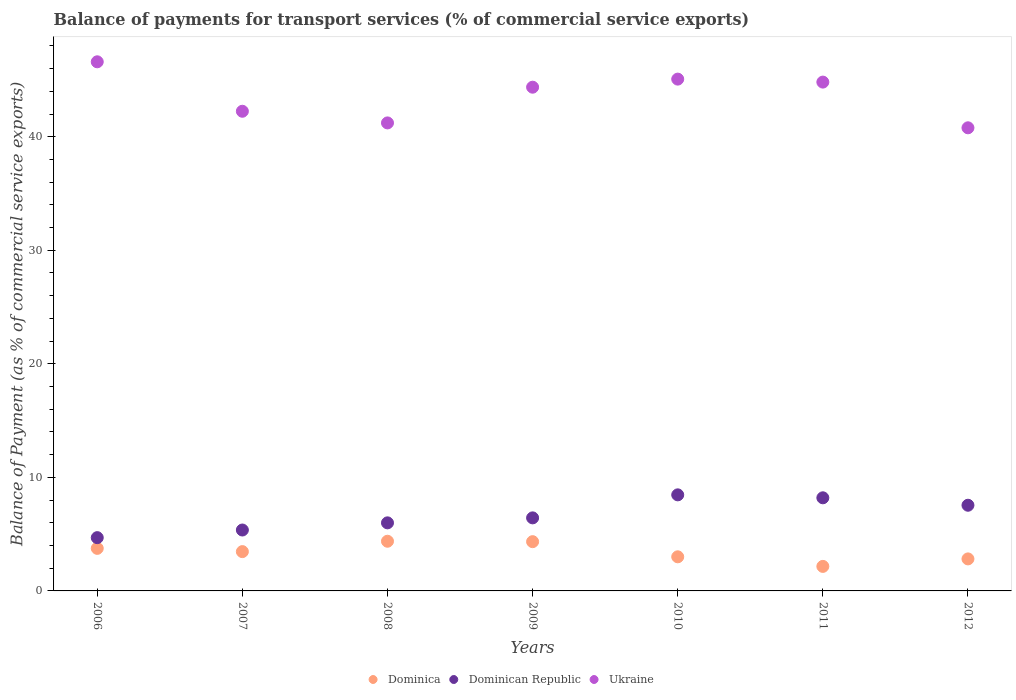How many different coloured dotlines are there?
Give a very brief answer. 3. Is the number of dotlines equal to the number of legend labels?
Your response must be concise. Yes. What is the balance of payments for transport services in Dominican Republic in 2007?
Provide a short and direct response. 5.36. Across all years, what is the maximum balance of payments for transport services in Dominica?
Make the answer very short. 4.37. Across all years, what is the minimum balance of payments for transport services in Dominica?
Provide a succinct answer. 2.16. In which year was the balance of payments for transport services in Dominican Republic maximum?
Your response must be concise. 2010. In which year was the balance of payments for transport services in Dominica minimum?
Your answer should be very brief. 2011. What is the total balance of payments for transport services in Dominican Republic in the graph?
Keep it short and to the point. 46.69. What is the difference between the balance of payments for transport services in Dominica in 2008 and that in 2012?
Your answer should be compact. 1.56. What is the difference between the balance of payments for transport services in Dominica in 2008 and the balance of payments for transport services in Ukraine in 2007?
Offer a terse response. -37.87. What is the average balance of payments for transport services in Ukraine per year?
Your response must be concise. 43.58. In the year 2010, what is the difference between the balance of payments for transport services in Dominican Republic and balance of payments for transport services in Ukraine?
Keep it short and to the point. -36.61. In how many years, is the balance of payments for transport services in Dominica greater than 18 %?
Your answer should be very brief. 0. What is the ratio of the balance of payments for transport services in Ukraine in 2007 to that in 2010?
Offer a very short reply. 0.94. Is the difference between the balance of payments for transport services in Dominican Republic in 2008 and 2010 greater than the difference between the balance of payments for transport services in Ukraine in 2008 and 2010?
Provide a succinct answer. Yes. What is the difference between the highest and the second highest balance of payments for transport services in Dominican Republic?
Provide a short and direct response. 0.26. What is the difference between the highest and the lowest balance of payments for transport services in Ukraine?
Provide a succinct answer. 5.81. Does the balance of payments for transport services in Dominica monotonically increase over the years?
Provide a short and direct response. No. How many dotlines are there?
Your response must be concise. 3. Are the values on the major ticks of Y-axis written in scientific E-notation?
Keep it short and to the point. No. Does the graph contain any zero values?
Keep it short and to the point. No. How many legend labels are there?
Keep it short and to the point. 3. What is the title of the graph?
Your answer should be very brief. Balance of payments for transport services (% of commercial service exports). What is the label or title of the Y-axis?
Offer a very short reply. Balance of Payment (as % of commercial service exports). What is the Balance of Payment (as % of commercial service exports) of Dominica in 2006?
Provide a short and direct response. 3.75. What is the Balance of Payment (as % of commercial service exports) in Dominican Republic in 2006?
Offer a terse response. 4.69. What is the Balance of Payment (as % of commercial service exports) in Ukraine in 2006?
Offer a terse response. 46.6. What is the Balance of Payment (as % of commercial service exports) of Dominica in 2007?
Give a very brief answer. 3.46. What is the Balance of Payment (as % of commercial service exports) in Dominican Republic in 2007?
Provide a succinct answer. 5.36. What is the Balance of Payment (as % of commercial service exports) in Ukraine in 2007?
Keep it short and to the point. 42.24. What is the Balance of Payment (as % of commercial service exports) of Dominica in 2008?
Ensure brevity in your answer.  4.37. What is the Balance of Payment (as % of commercial service exports) in Dominican Republic in 2008?
Give a very brief answer. 5.99. What is the Balance of Payment (as % of commercial service exports) in Ukraine in 2008?
Keep it short and to the point. 41.22. What is the Balance of Payment (as % of commercial service exports) of Dominica in 2009?
Ensure brevity in your answer.  4.34. What is the Balance of Payment (as % of commercial service exports) in Dominican Republic in 2009?
Offer a terse response. 6.43. What is the Balance of Payment (as % of commercial service exports) of Ukraine in 2009?
Give a very brief answer. 44.36. What is the Balance of Payment (as % of commercial service exports) of Dominica in 2010?
Offer a very short reply. 3. What is the Balance of Payment (as % of commercial service exports) in Dominican Republic in 2010?
Offer a very short reply. 8.46. What is the Balance of Payment (as % of commercial service exports) of Ukraine in 2010?
Provide a short and direct response. 45.07. What is the Balance of Payment (as % of commercial service exports) in Dominica in 2011?
Provide a short and direct response. 2.16. What is the Balance of Payment (as % of commercial service exports) of Dominican Republic in 2011?
Keep it short and to the point. 8.2. What is the Balance of Payment (as % of commercial service exports) in Ukraine in 2011?
Your answer should be compact. 44.81. What is the Balance of Payment (as % of commercial service exports) in Dominica in 2012?
Give a very brief answer. 2.82. What is the Balance of Payment (as % of commercial service exports) in Dominican Republic in 2012?
Provide a short and direct response. 7.55. What is the Balance of Payment (as % of commercial service exports) of Ukraine in 2012?
Your response must be concise. 40.79. Across all years, what is the maximum Balance of Payment (as % of commercial service exports) in Dominica?
Provide a succinct answer. 4.37. Across all years, what is the maximum Balance of Payment (as % of commercial service exports) in Dominican Republic?
Ensure brevity in your answer.  8.46. Across all years, what is the maximum Balance of Payment (as % of commercial service exports) in Ukraine?
Ensure brevity in your answer.  46.6. Across all years, what is the minimum Balance of Payment (as % of commercial service exports) in Dominica?
Your response must be concise. 2.16. Across all years, what is the minimum Balance of Payment (as % of commercial service exports) of Dominican Republic?
Give a very brief answer. 4.69. Across all years, what is the minimum Balance of Payment (as % of commercial service exports) in Ukraine?
Make the answer very short. 40.79. What is the total Balance of Payment (as % of commercial service exports) of Dominica in the graph?
Offer a terse response. 23.9. What is the total Balance of Payment (as % of commercial service exports) of Dominican Republic in the graph?
Offer a very short reply. 46.69. What is the total Balance of Payment (as % of commercial service exports) of Ukraine in the graph?
Your answer should be compact. 305.09. What is the difference between the Balance of Payment (as % of commercial service exports) of Dominica in 2006 and that in 2007?
Make the answer very short. 0.29. What is the difference between the Balance of Payment (as % of commercial service exports) of Dominican Republic in 2006 and that in 2007?
Ensure brevity in your answer.  -0.67. What is the difference between the Balance of Payment (as % of commercial service exports) of Ukraine in 2006 and that in 2007?
Offer a terse response. 4.36. What is the difference between the Balance of Payment (as % of commercial service exports) in Dominica in 2006 and that in 2008?
Your answer should be compact. -0.63. What is the difference between the Balance of Payment (as % of commercial service exports) in Dominican Republic in 2006 and that in 2008?
Ensure brevity in your answer.  -1.3. What is the difference between the Balance of Payment (as % of commercial service exports) in Ukraine in 2006 and that in 2008?
Provide a succinct answer. 5.38. What is the difference between the Balance of Payment (as % of commercial service exports) of Dominica in 2006 and that in 2009?
Your answer should be very brief. -0.59. What is the difference between the Balance of Payment (as % of commercial service exports) in Dominican Republic in 2006 and that in 2009?
Offer a very short reply. -1.74. What is the difference between the Balance of Payment (as % of commercial service exports) in Ukraine in 2006 and that in 2009?
Your response must be concise. 2.24. What is the difference between the Balance of Payment (as % of commercial service exports) of Dominica in 2006 and that in 2010?
Offer a very short reply. 0.74. What is the difference between the Balance of Payment (as % of commercial service exports) in Dominican Republic in 2006 and that in 2010?
Make the answer very short. -3.77. What is the difference between the Balance of Payment (as % of commercial service exports) of Ukraine in 2006 and that in 2010?
Your answer should be very brief. 1.52. What is the difference between the Balance of Payment (as % of commercial service exports) of Dominica in 2006 and that in 2011?
Give a very brief answer. 1.59. What is the difference between the Balance of Payment (as % of commercial service exports) of Dominican Republic in 2006 and that in 2011?
Keep it short and to the point. -3.51. What is the difference between the Balance of Payment (as % of commercial service exports) of Ukraine in 2006 and that in 2011?
Offer a very short reply. 1.79. What is the difference between the Balance of Payment (as % of commercial service exports) of Dominica in 2006 and that in 2012?
Make the answer very short. 0.93. What is the difference between the Balance of Payment (as % of commercial service exports) in Dominican Republic in 2006 and that in 2012?
Provide a succinct answer. -2.85. What is the difference between the Balance of Payment (as % of commercial service exports) of Ukraine in 2006 and that in 2012?
Your answer should be very brief. 5.81. What is the difference between the Balance of Payment (as % of commercial service exports) in Dominica in 2007 and that in 2008?
Ensure brevity in your answer.  -0.91. What is the difference between the Balance of Payment (as % of commercial service exports) in Dominican Republic in 2007 and that in 2008?
Your answer should be compact. -0.63. What is the difference between the Balance of Payment (as % of commercial service exports) in Ukraine in 2007 and that in 2008?
Offer a very short reply. 1.03. What is the difference between the Balance of Payment (as % of commercial service exports) in Dominica in 2007 and that in 2009?
Offer a very short reply. -0.88. What is the difference between the Balance of Payment (as % of commercial service exports) of Dominican Republic in 2007 and that in 2009?
Provide a short and direct response. -1.07. What is the difference between the Balance of Payment (as % of commercial service exports) of Ukraine in 2007 and that in 2009?
Provide a short and direct response. -2.12. What is the difference between the Balance of Payment (as % of commercial service exports) in Dominica in 2007 and that in 2010?
Provide a succinct answer. 0.46. What is the difference between the Balance of Payment (as % of commercial service exports) in Dominican Republic in 2007 and that in 2010?
Your answer should be compact. -3.1. What is the difference between the Balance of Payment (as % of commercial service exports) in Ukraine in 2007 and that in 2010?
Your answer should be very brief. -2.83. What is the difference between the Balance of Payment (as % of commercial service exports) of Dominica in 2007 and that in 2011?
Keep it short and to the point. 1.3. What is the difference between the Balance of Payment (as % of commercial service exports) in Dominican Republic in 2007 and that in 2011?
Keep it short and to the point. -2.84. What is the difference between the Balance of Payment (as % of commercial service exports) in Ukraine in 2007 and that in 2011?
Your answer should be compact. -2.57. What is the difference between the Balance of Payment (as % of commercial service exports) of Dominica in 2007 and that in 2012?
Your response must be concise. 0.64. What is the difference between the Balance of Payment (as % of commercial service exports) in Dominican Republic in 2007 and that in 2012?
Make the answer very short. -2.18. What is the difference between the Balance of Payment (as % of commercial service exports) of Ukraine in 2007 and that in 2012?
Your answer should be very brief. 1.46. What is the difference between the Balance of Payment (as % of commercial service exports) of Dominica in 2008 and that in 2009?
Ensure brevity in your answer.  0.04. What is the difference between the Balance of Payment (as % of commercial service exports) in Dominican Republic in 2008 and that in 2009?
Provide a succinct answer. -0.44. What is the difference between the Balance of Payment (as % of commercial service exports) of Ukraine in 2008 and that in 2009?
Ensure brevity in your answer.  -3.15. What is the difference between the Balance of Payment (as % of commercial service exports) in Dominica in 2008 and that in 2010?
Your response must be concise. 1.37. What is the difference between the Balance of Payment (as % of commercial service exports) in Dominican Republic in 2008 and that in 2010?
Your response must be concise. -2.47. What is the difference between the Balance of Payment (as % of commercial service exports) in Ukraine in 2008 and that in 2010?
Provide a succinct answer. -3.86. What is the difference between the Balance of Payment (as % of commercial service exports) of Dominica in 2008 and that in 2011?
Your answer should be compact. 2.21. What is the difference between the Balance of Payment (as % of commercial service exports) in Dominican Republic in 2008 and that in 2011?
Give a very brief answer. -2.21. What is the difference between the Balance of Payment (as % of commercial service exports) in Ukraine in 2008 and that in 2011?
Give a very brief answer. -3.59. What is the difference between the Balance of Payment (as % of commercial service exports) of Dominica in 2008 and that in 2012?
Offer a very short reply. 1.56. What is the difference between the Balance of Payment (as % of commercial service exports) of Dominican Republic in 2008 and that in 2012?
Your answer should be compact. -1.55. What is the difference between the Balance of Payment (as % of commercial service exports) of Ukraine in 2008 and that in 2012?
Ensure brevity in your answer.  0.43. What is the difference between the Balance of Payment (as % of commercial service exports) in Dominica in 2009 and that in 2010?
Offer a very short reply. 1.33. What is the difference between the Balance of Payment (as % of commercial service exports) in Dominican Republic in 2009 and that in 2010?
Make the answer very short. -2.03. What is the difference between the Balance of Payment (as % of commercial service exports) of Ukraine in 2009 and that in 2010?
Provide a succinct answer. -0.71. What is the difference between the Balance of Payment (as % of commercial service exports) of Dominica in 2009 and that in 2011?
Provide a short and direct response. 2.18. What is the difference between the Balance of Payment (as % of commercial service exports) in Dominican Republic in 2009 and that in 2011?
Offer a terse response. -1.77. What is the difference between the Balance of Payment (as % of commercial service exports) of Ukraine in 2009 and that in 2011?
Your response must be concise. -0.45. What is the difference between the Balance of Payment (as % of commercial service exports) of Dominica in 2009 and that in 2012?
Provide a succinct answer. 1.52. What is the difference between the Balance of Payment (as % of commercial service exports) of Dominican Republic in 2009 and that in 2012?
Make the answer very short. -1.11. What is the difference between the Balance of Payment (as % of commercial service exports) in Ukraine in 2009 and that in 2012?
Your answer should be compact. 3.58. What is the difference between the Balance of Payment (as % of commercial service exports) in Dominica in 2010 and that in 2011?
Provide a short and direct response. 0.84. What is the difference between the Balance of Payment (as % of commercial service exports) of Dominican Republic in 2010 and that in 2011?
Offer a terse response. 0.26. What is the difference between the Balance of Payment (as % of commercial service exports) in Ukraine in 2010 and that in 2011?
Give a very brief answer. 0.26. What is the difference between the Balance of Payment (as % of commercial service exports) in Dominica in 2010 and that in 2012?
Provide a succinct answer. 0.18. What is the difference between the Balance of Payment (as % of commercial service exports) of Dominican Republic in 2010 and that in 2012?
Provide a short and direct response. 0.91. What is the difference between the Balance of Payment (as % of commercial service exports) in Ukraine in 2010 and that in 2012?
Your answer should be very brief. 4.29. What is the difference between the Balance of Payment (as % of commercial service exports) in Dominica in 2011 and that in 2012?
Make the answer very short. -0.66. What is the difference between the Balance of Payment (as % of commercial service exports) in Dominican Republic in 2011 and that in 2012?
Your response must be concise. 0.65. What is the difference between the Balance of Payment (as % of commercial service exports) of Ukraine in 2011 and that in 2012?
Make the answer very short. 4.03. What is the difference between the Balance of Payment (as % of commercial service exports) in Dominica in 2006 and the Balance of Payment (as % of commercial service exports) in Dominican Republic in 2007?
Provide a succinct answer. -1.62. What is the difference between the Balance of Payment (as % of commercial service exports) in Dominica in 2006 and the Balance of Payment (as % of commercial service exports) in Ukraine in 2007?
Keep it short and to the point. -38.49. What is the difference between the Balance of Payment (as % of commercial service exports) in Dominican Republic in 2006 and the Balance of Payment (as % of commercial service exports) in Ukraine in 2007?
Offer a very short reply. -37.55. What is the difference between the Balance of Payment (as % of commercial service exports) of Dominica in 2006 and the Balance of Payment (as % of commercial service exports) of Dominican Republic in 2008?
Provide a succinct answer. -2.25. What is the difference between the Balance of Payment (as % of commercial service exports) in Dominica in 2006 and the Balance of Payment (as % of commercial service exports) in Ukraine in 2008?
Keep it short and to the point. -37.47. What is the difference between the Balance of Payment (as % of commercial service exports) in Dominican Republic in 2006 and the Balance of Payment (as % of commercial service exports) in Ukraine in 2008?
Give a very brief answer. -36.52. What is the difference between the Balance of Payment (as % of commercial service exports) in Dominica in 2006 and the Balance of Payment (as % of commercial service exports) in Dominican Republic in 2009?
Your answer should be compact. -2.69. What is the difference between the Balance of Payment (as % of commercial service exports) in Dominica in 2006 and the Balance of Payment (as % of commercial service exports) in Ukraine in 2009?
Offer a terse response. -40.61. What is the difference between the Balance of Payment (as % of commercial service exports) of Dominican Republic in 2006 and the Balance of Payment (as % of commercial service exports) of Ukraine in 2009?
Offer a very short reply. -39.67. What is the difference between the Balance of Payment (as % of commercial service exports) of Dominica in 2006 and the Balance of Payment (as % of commercial service exports) of Dominican Republic in 2010?
Provide a short and direct response. -4.71. What is the difference between the Balance of Payment (as % of commercial service exports) of Dominica in 2006 and the Balance of Payment (as % of commercial service exports) of Ukraine in 2010?
Provide a short and direct response. -41.33. What is the difference between the Balance of Payment (as % of commercial service exports) in Dominican Republic in 2006 and the Balance of Payment (as % of commercial service exports) in Ukraine in 2010?
Your answer should be compact. -40.38. What is the difference between the Balance of Payment (as % of commercial service exports) in Dominica in 2006 and the Balance of Payment (as % of commercial service exports) in Dominican Republic in 2011?
Your answer should be very brief. -4.45. What is the difference between the Balance of Payment (as % of commercial service exports) in Dominica in 2006 and the Balance of Payment (as % of commercial service exports) in Ukraine in 2011?
Your answer should be compact. -41.06. What is the difference between the Balance of Payment (as % of commercial service exports) in Dominican Republic in 2006 and the Balance of Payment (as % of commercial service exports) in Ukraine in 2011?
Provide a succinct answer. -40.12. What is the difference between the Balance of Payment (as % of commercial service exports) of Dominica in 2006 and the Balance of Payment (as % of commercial service exports) of Dominican Republic in 2012?
Make the answer very short. -3.8. What is the difference between the Balance of Payment (as % of commercial service exports) of Dominica in 2006 and the Balance of Payment (as % of commercial service exports) of Ukraine in 2012?
Give a very brief answer. -37.04. What is the difference between the Balance of Payment (as % of commercial service exports) in Dominican Republic in 2006 and the Balance of Payment (as % of commercial service exports) in Ukraine in 2012?
Provide a succinct answer. -36.09. What is the difference between the Balance of Payment (as % of commercial service exports) of Dominica in 2007 and the Balance of Payment (as % of commercial service exports) of Dominican Republic in 2008?
Give a very brief answer. -2.53. What is the difference between the Balance of Payment (as % of commercial service exports) of Dominica in 2007 and the Balance of Payment (as % of commercial service exports) of Ukraine in 2008?
Give a very brief answer. -37.75. What is the difference between the Balance of Payment (as % of commercial service exports) of Dominican Republic in 2007 and the Balance of Payment (as % of commercial service exports) of Ukraine in 2008?
Ensure brevity in your answer.  -35.85. What is the difference between the Balance of Payment (as % of commercial service exports) in Dominica in 2007 and the Balance of Payment (as % of commercial service exports) in Dominican Republic in 2009?
Keep it short and to the point. -2.97. What is the difference between the Balance of Payment (as % of commercial service exports) of Dominica in 2007 and the Balance of Payment (as % of commercial service exports) of Ukraine in 2009?
Offer a terse response. -40.9. What is the difference between the Balance of Payment (as % of commercial service exports) in Dominican Republic in 2007 and the Balance of Payment (as % of commercial service exports) in Ukraine in 2009?
Keep it short and to the point. -39. What is the difference between the Balance of Payment (as % of commercial service exports) in Dominica in 2007 and the Balance of Payment (as % of commercial service exports) in Dominican Republic in 2010?
Make the answer very short. -5. What is the difference between the Balance of Payment (as % of commercial service exports) in Dominica in 2007 and the Balance of Payment (as % of commercial service exports) in Ukraine in 2010?
Your response must be concise. -41.61. What is the difference between the Balance of Payment (as % of commercial service exports) in Dominican Republic in 2007 and the Balance of Payment (as % of commercial service exports) in Ukraine in 2010?
Offer a very short reply. -39.71. What is the difference between the Balance of Payment (as % of commercial service exports) in Dominica in 2007 and the Balance of Payment (as % of commercial service exports) in Dominican Republic in 2011?
Offer a very short reply. -4.74. What is the difference between the Balance of Payment (as % of commercial service exports) of Dominica in 2007 and the Balance of Payment (as % of commercial service exports) of Ukraine in 2011?
Offer a very short reply. -41.35. What is the difference between the Balance of Payment (as % of commercial service exports) of Dominican Republic in 2007 and the Balance of Payment (as % of commercial service exports) of Ukraine in 2011?
Your answer should be very brief. -39.45. What is the difference between the Balance of Payment (as % of commercial service exports) of Dominica in 2007 and the Balance of Payment (as % of commercial service exports) of Dominican Republic in 2012?
Offer a terse response. -4.08. What is the difference between the Balance of Payment (as % of commercial service exports) in Dominica in 2007 and the Balance of Payment (as % of commercial service exports) in Ukraine in 2012?
Provide a short and direct response. -37.32. What is the difference between the Balance of Payment (as % of commercial service exports) in Dominican Republic in 2007 and the Balance of Payment (as % of commercial service exports) in Ukraine in 2012?
Ensure brevity in your answer.  -35.42. What is the difference between the Balance of Payment (as % of commercial service exports) of Dominica in 2008 and the Balance of Payment (as % of commercial service exports) of Dominican Republic in 2009?
Your answer should be very brief. -2.06. What is the difference between the Balance of Payment (as % of commercial service exports) of Dominica in 2008 and the Balance of Payment (as % of commercial service exports) of Ukraine in 2009?
Offer a terse response. -39.99. What is the difference between the Balance of Payment (as % of commercial service exports) of Dominican Republic in 2008 and the Balance of Payment (as % of commercial service exports) of Ukraine in 2009?
Ensure brevity in your answer.  -38.37. What is the difference between the Balance of Payment (as % of commercial service exports) in Dominica in 2008 and the Balance of Payment (as % of commercial service exports) in Dominican Republic in 2010?
Make the answer very short. -4.09. What is the difference between the Balance of Payment (as % of commercial service exports) in Dominica in 2008 and the Balance of Payment (as % of commercial service exports) in Ukraine in 2010?
Offer a very short reply. -40.7. What is the difference between the Balance of Payment (as % of commercial service exports) of Dominican Republic in 2008 and the Balance of Payment (as % of commercial service exports) of Ukraine in 2010?
Provide a short and direct response. -39.08. What is the difference between the Balance of Payment (as % of commercial service exports) of Dominica in 2008 and the Balance of Payment (as % of commercial service exports) of Dominican Republic in 2011?
Provide a succinct answer. -3.83. What is the difference between the Balance of Payment (as % of commercial service exports) of Dominica in 2008 and the Balance of Payment (as % of commercial service exports) of Ukraine in 2011?
Offer a very short reply. -40.44. What is the difference between the Balance of Payment (as % of commercial service exports) of Dominican Republic in 2008 and the Balance of Payment (as % of commercial service exports) of Ukraine in 2011?
Ensure brevity in your answer.  -38.82. What is the difference between the Balance of Payment (as % of commercial service exports) in Dominica in 2008 and the Balance of Payment (as % of commercial service exports) in Dominican Republic in 2012?
Your answer should be compact. -3.17. What is the difference between the Balance of Payment (as % of commercial service exports) in Dominica in 2008 and the Balance of Payment (as % of commercial service exports) in Ukraine in 2012?
Ensure brevity in your answer.  -36.41. What is the difference between the Balance of Payment (as % of commercial service exports) of Dominican Republic in 2008 and the Balance of Payment (as % of commercial service exports) of Ukraine in 2012?
Ensure brevity in your answer.  -34.79. What is the difference between the Balance of Payment (as % of commercial service exports) in Dominica in 2009 and the Balance of Payment (as % of commercial service exports) in Dominican Republic in 2010?
Provide a succinct answer. -4.12. What is the difference between the Balance of Payment (as % of commercial service exports) of Dominica in 2009 and the Balance of Payment (as % of commercial service exports) of Ukraine in 2010?
Offer a very short reply. -40.74. What is the difference between the Balance of Payment (as % of commercial service exports) in Dominican Republic in 2009 and the Balance of Payment (as % of commercial service exports) in Ukraine in 2010?
Make the answer very short. -38.64. What is the difference between the Balance of Payment (as % of commercial service exports) in Dominica in 2009 and the Balance of Payment (as % of commercial service exports) in Dominican Republic in 2011?
Ensure brevity in your answer.  -3.86. What is the difference between the Balance of Payment (as % of commercial service exports) in Dominica in 2009 and the Balance of Payment (as % of commercial service exports) in Ukraine in 2011?
Offer a very short reply. -40.47. What is the difference between the Balance of Payment (as % of commercial service exports) of Dominican Republic in 2009 and the Balance of Payment (as % of commercial service exports) of Ukraine in 2011?
Your answer should be compact. -38.38. What is the difference between the Balance of Payment (as % of commercial service exports) of Dominica in 2009 and the Balance of Payment (as % of commercial service exports) of Dominican Republic in 2012?
Your answer should be very brief. -3.21. What is the difference between the Balance of Payment (as % of commercial service exports) in Dominica in 2009 and the Balance of Payment (as % of commercial service exports) in Ukraine in 2012?
Your answer should be compact. -36.45. What is the difference between the Balance of Payment (as % of commercial service exports) of Dominican Republic in 2009 and the Balance of Payment (as % of commercial service exports) of Ukraine in 2012?
Keep it short and to the point. -34.35. What is the difference between the Balance of Payment (as % of commercial service exports) in Dominica in 2010 and the Balance of Payment (as % of commercial service exports) in Dominican Republic in 2011?
Give a very brief answer. -5.2. What is the difference between the Balance of Payment (as % of commercial service exports) of Dominica in 2010 and the Balance of Payment (as % of commercial service exports) of Ukraine in 2011?
Make the answer very short. -41.81. What is the difference between the Balance of Payment (as % of commercial service exports) in Dominican Republic in 2010 and the Balance of Payment (as % of commercial service exports) in Ukraine in 2011?
Ensure brevity in your answer.  -36.35. What is the difference between the Balance of Payment (as % of commercial service exports) of Dominica in 2010 and the Balance of Payment (as % of commercial service exports) of Dominican Republic in 2012?
Your answer should be compact. -4.54. What is the difference between the Balance of Payment (as % of commercial service exports) in Dominica in 2010 and the Balance of Payment (as % of commercial service exports) in Ukraine in 2012?
Your answer should be very brief. -37.78. What is the difference between the Balance of Payment (as % of commercial service exports) of Dominican Republic in 2010 and the Balance of Payment (as % of commercial service exports) of Ukraine in 2012?
Your answer should be very brief. -32.32. What is the difference between the Balance of Payment (as % of commercial service exports) in Dominica in 2011 and the Balance of Payment (as % of commercial service exports) in Dominican Republic in 2012?
Offer a terse response. -5.39. What is the difference between the Balance of Payment (as % of commercial service exports) in Dominica in 2011 and the Balance of Payment (as % of commercial service exports) in Ukraine in 2012?
Your answer should be very brief. -38.63. What is the difference between the Balance of Payment (as % of commercial service exports) of Dominican Republic in 2011 and the Balance of Payment (as % of commercial service exports) of Ukraine in 2012?
Keep it short and to the point. -32.58. What is the average Balance of Payment (as % of commercial service exports) in Dominica per year?
Give a very brief answer. 3.42. What is the average Balance of Payment (as % of commercial service exports) in Dominican Republic per year?
Offer a terse response. 6.67. What is the average Balance of Payment (as % of commercial service exports) of Ukraine per year?
Offer a terse response. 43.58. In the year 2006, what is the difference between the Balance of Payment (as % of commercial service exports) of Dominica and Balance of Payment (as % of commercial service exports) of Dominican Republic?
Ensure brevity in your answer.  -0.94. In the year 2006, what is the difference between the Balance of Payment (as % of commercial service exports) in Dominica and Balance of Payment (as % of commercial service exports) in Ukraine?
Provide a succinct answer. -42.85. In the year 2006, what is the difference between the Balance of Payment (as % of commercial service exports) in Dominican Republic and Balance of Payment (as % of commercial service exports) in Ukraine?
Make the answer very short. -41.91. In the year 2007, what is the difference between the Balance of Payment (as % of commercial service exports) of Dominica and Balance of Payment (as % of commercial service exports) of Dominican Republic?
Ensure brevity in your answer.  -1.9. In the year 2007, what is the difference between the Balance of Payment (as % of commercial service exports) in Dominica and Balance of Payment (as % of commercial service exports) in Ukraine?
Provide a succinct answer. -38.78. In the year 2007, what is the difference between the Balance of Payment (as % of commercial service exports) in Dominican Republic and Balance of Payment (as % of commercial service exports) in Ukraine?
Your answer should be compact. -36.88. In the year 2008, what is the difference between the Balance of Payment (as % of commercial service exports) of Dominica and Balance of Payment (as % of commercial service exports) of Dominican Republic?
Make the answer very short. -1.62. In the year 2008, what is the difference between the Balance of Payment (as % of commercial service exports) in Dominica and Balance of Payment (as % of commercial service exports) in Ukraine?
Offer a very short reply. -36.84. In the year 2008, what is the difference between the Balance of Payment (as % of commercial service exports) of Dominican Republic and Balance of Payment (as % of commercial service exports) of Ukraine?
Offer a very short reply. -35.22. In the year 2009, what is the difference between the Balance of Payment (as % of commercial service exports) of Dominica and Balance of Payment (as % of commercial service exports) of Dominican Republic?
Your response must be concise. -2.1. In the year 2009, what is the difference between the Balance of Payment (as % of commercial service exports) in Dominica and Balance of Payment (as % of commercial service exports) in Ukraine?
Keep it short and to the point. -40.02. In the year 2009, what is the difference between the Balance of Payment (as % of commercial service exports) of Dominican Republic and Balance of Payment (as % of commercial service exports) of Ukraine?
Provide a succinct answer. -37.93. In the year 2010, what is the difference between the Balance of Payment (as % of commercial service exports) of Dominica and Balance of Payment (as % of commercial service exports) of Dominican Republic?
Offer a terse response. -5.46. In the year 2010, what is the difference between the Balance of Payment (as % of commercial service exports) of Dominica and Balance of Payment (as % of commercial service exports) of Ukraine?
Ensure brevity in your answer.  -42.07. In the year 2010, what is the difference between the Balance of Payment (as % of commercial service exports) of Dominican Republic and Balance of Payment (as % of commercial service exports) of Ukraine?
Your response must be concise. -36.61. In the year 2011, what is the difference between the Balance of Payment (as % of commercial service exports) of Dominica and Balance of Payment (as % of commercial service exports) of Dominican Republic?
Provide a short and direct response. -6.04. In the year 2011, what is the difference between the Balance of Payment (as % of commercial service exports) in Dominica and Balance of Payment (as % of commercial service exports) in Ukraine?
Your answer should be compact. -42.65. In the year 2011, what is the difference between the Balance of Payment (as % of commercial service exports) of Dominican Republic and Balance of Payment (as % of commercial service exports) of Ukraine?
Give a very brief answer. -36.61. In the year 2012, what is the difference between the Balance of Payment (as % of commercial service exports) of Dominica and Balance of Payment (as % of commercial service exports) of Dominican Republic?
Give a very brief answer. -4.73. In the year 2012, what is the difference between the Balance of Payment (as % of commercial service exports) of Dominica and Balance of Payment (as % of commercial service exports) of Ukraine?
Keep it short and to the point. -37.97. In the year 2012, what is the difference between the Balance of Payment (as % of commercial service exports) in Dominican Republic and Balance of Payment (as % of commercial service exports) in Ukraine?
Your answer should be very brief. -33.24. What is the ratio of the Balance of Payment (as % of commercial service exports) in Dominica in 2006 to that in 2007?
Ensure brevity in your answer.  1.08. What is the ratio of the Balance of Payment (as % of commercial service exports) in Dominican Republic in 2006 to that in 2007?
Provide a succinct answer. 0.87. What is the ratio of the Balance of Payment (as % of commercial service exports) in Ukraine in 2006 to that in 2007?
Offer a very short reply. 1.1. What is the ratio of the Balance of Payment (as % of commercial service exports) in Dominica in 2006 to that in 2008?
Your response must be concise. 0.86. What is the ratio of the Balance of Payment (as % of commercial service exports) of Dominican Republic in 2006 to that in 2008?
Make the answer very short. 0.78. What is the ratio of the Balance of Payment (as % of commercial service exports) in Ukraine in 2006 to that in 2008?
Give a very brief answer. 1.13. What is the ratio of the Balance of Payment (as % of commercial service exports) in Dominica in 2006 to that in 2009?
Your answer should be compact. 0.86. What is the ratio of the Balance of Payment (as % of commercial service exports) in Dominican Republic in 2006 to that in 2009?
Give a very brief answer. 0.73. What is the ratio of the Balance of Payment (as % of commercial service exports) in Ukraine in 2006 to that in 2009?
Your answer should be very brief. 1.05. What is the ratio of the Balance of Payment (as % of commercial service exports) of Dominica in 2006 to that in 2010?
Make the answer very short. 1.25. What is the ratio of the Balance of Payment (as % of commercial service exports) in Dominican Republic in 2006 to that in 2010?
Your response must be concise. 0.55. What is the ratio of the Balance of Payment (as % of commercial service exports) of Ukraine in 2006 to that in 2010?
Ensure brevity in your answer.  1.03. What is the ratio of the Balance of Payment (as % of commercial service exports) in Dominica in 2006 to that in 2011?
Provide a short and direct response. 1.74. What is the ratio of the Balance of Payment (as % of commercial service exports) of Dominican Republic in 2006 to that in 2011?
Offer a terse response. 0.57. What is the ratio of the Balance of Payment (as % of commercial service exports) in Ukraine in 2006 to that in 2011?
Make the answer very short. 1.04. What is the ratio of the Balance of Payment (as % of commercial service exports) in Dominica in 2006 to that in 2012?
Your answer should be compact. 1.33. What is the ratio of the Balance of Payment (as % of commercial service exports) of Dominican Republic in 2006 to that in 2012?
Ensure brevity in your answer.  0.62. What is the ratio of the Balance of Payment (as % of commercial service exports) of Ukraine in 2006 to that in 2012?
Ensure brevity in your answer.  1.14. What is the ratio of the Balance of Payment (as % of commercial service exports) of Dominica in 2007 to that in 2008?
Your answer should be very brief. 0.79. What is the ratio of the Balance of Payment (as % of commercial service exports) in Dominican Republic in 2007 to that in 2008?
Provide a short and direct response. 0.89. What is the ratio of the Balance of Payment (as % of commercial service exports) in Ukraine in 2007 to that in 2008?
Make the answer very short. 1.02. What is the ratio of the Balance of Payment (as % of commercial service exports) in Dominica in 2007 to that in 2009?
Ensure brevity in your answer.  0.8. What is the ratio of the Balance of Payment (as % of commercial service exports) in Dominican Republic in 2007 to that in 2009?
Ensure brevity in your answer.  0.83. What is the ratio of the Balance of Payment (as % of commercial service exports) of Ukraine in 2007 to that in 2009?
Make the answer very short. 0.95. What is the ratio of the Balance of Payment (as % of commercial service exports) of Dominica in 2007 to that in 2010?
Offer a very short reply. 1.15. What is the ratio of the Balance of Payment (as % of commercial service exports) of Dominican Republic in 2007 to that in 2010?
Ensure brevity in your answer.  0.63. What is the ratio of the Balance of Payment (as % of commercial service exports) of Ukraine in 2007 to that in 2010?
Provide a succinct answer. 0.94. What is the ratio of the Balance of Payment (as % of commercial service exports) in Dominica in 2007 to that in 2011?
Your response must be concise. 1.6. What is the ratio of the Balance of Payment (as % of commercial service exports) in Dominican Republic in 2007 to that in 2011?
Provide a succinct answer. 0.65. What is the ratio of the Balance of Payment (as % of commercial service exports) in Ukraine in 2007 to that in 2011?
Make the answer very short. 0.94. What is the ratio of the Balance of Payment (as % of commercial service exports) of Dominica in 2007 to that in 2012?
Provide a succinct answer. 1.23. What is the ratio of the Balance of Payment (as % of commercial service exports) of Dominican Republic in 2007 to that in 2012?
Your answer should be very brief. 0.71. What is the ratio of the Balance of Payment (as % of commercial service exports) of Ukraine in 2007 to that in 2012?
Provide a succinct answer. 1.04. What is the ratio of the Balance of Payment (as % of commercial service exports) in Dominica in 2008 to that in 2009?
Keep it short and to the point. 1.01. What is the ratio of the Balance of Payment (as % of commercial service exports) of Dominican Republic in 2008 to that in 2009?
Offer a very short reply. 0.93. What is the ratio of the Balance of Payment (as % of commercial service exports) of Ukraine in 2008 to that in 2009?
Make the answer very short. 0.93. What is the ratio of the Balance of Payment (as % of commercial service exports) of Dominica in 2008 to that in 2010?
Your answer should be compact. 1.46. What is the ratio of the Balance of Payment (as % of commercial service exports) of Dominican Republic in 2008 to that in 2010?
Make the answer very short. 0.71. What is the ratio of the Balance of Payment (as % of commercial service exports) in Ukraine in 2008 to that in 2010?
Keep it short and to the point. 0.91. What is the ratio of the Balance of Payment (as % of commercial service exports) of Dominica in 2008 to that in 2011?
Offer a terse response. 2.03. What is the ratio of the Balance of Payment (as % of commercial service exports) in Dominican Republic in 2008 to that in 2011?
Ensure brevity in your answer.  0.73. What is the ratio of the Balance of Payment (as % of commercial service exports) of Ukraine in 2008 to that in 2011?
Your answer should be compact. 0.92. What is the ratio of the Balance of Payment (as % of commercial service exports) in Dominica in 2008 to that in 2012?
Provide a short and direct response. 1.55. What is the ratio of the Balance of Payment (as % of commercial service exports) of Dominican Republic in 2008 to that in 2012?
Give a very brief answer. 0.79. What is the ratio of the Balance of Payment (as % of commercial service exports) in Ukraine in 2008 to that in 2012?
Provide a short and direct response. 1.01. What is the ratio of the Balance of Payment (as % of commercial service exports) of Dominica in 2009 to that in 2010?
Your answer should be very brief. 1.44. What is the ratio of the Balance of Payment (as % of commercial service exports) of Dominican Republic in 2009 to that in 2010?
Your answer should be very brief. 0.76. What is the ratio of the Balance of Payment (as % of commercial service exports) of Ukraine in 2009 to that in 2010?
Provide a succinct answer. 0.98. What is the ratio of the Balance of Payment (as % of commercial service exports) of Dominica in 2009 to that in 2011?
Provide a succinct answer. 2.01. What is the ratio of the Balance of Payment (as % of commercial service exports) in Dominican Republic in 2009 to that in 2011?
Provide a succinct answer. 0.78. What is the ratio of the Balance of Payment (as % of commercial service exports) in Dominica in 2009 to that in 2012?
Keep it short and to the point. 1.54. What is the ratio of the Balance of Payment (as % of commercial service exports) of Dominican Republic in 2009 to that in 2012?
Give a very brief answer. 0.85. What is the ratio of the Balance of Payment (as % of commercial service exports) of Ukraine in 2009 to that in 2012?
Your response must be concise. 1.09. What is the ratio of the Balance of Payment (as % of commercial service exports) in Dominica in 2010 to that in 2011?
Offer a very short reply. 1.39. What is the ratio of the Balance of Payment (as % of commercial service exports) in Dominican Republic in 2010 to that in 2011?
Ensure brevity in your answer.  1.03. What is the ratio of the Balance of Payment (as % of commercial service exports) in Ukraine in 2010 to that in 2011?
Ensure brevity in your answer.  1.01. What is the ratio of the Balance of Payment (as % of commercial service exports) in Dominica in 2010 to that in 2012?
Provide a short and direct response. 1.07. What is the ratio of the Balance of Payment (as % of commercial service exports) of Dominican Republic in 2010 to that in 2012?
Your response must be concise. 1.12. What is the ratio of the Balance of Payment (as % of commercial service exports) in Ukraine in 2010 to that in 2012?
Provide a short and direct response. 1.11. What is the ratio of the Balance of Payment (as % of commercial service exports) in Dominica in 2011 to that in 2012?
Offer a very short reply. 0.77. What is the ratio of the Balance of Payment (as % of commercial service exports) in Dominican Republic in 2011 to that in 2012?
Give a very brief answer. 1.09. What is the ratio of the Balance of Payment (as % of commercial service exports) in Ukraine in 2011 to that in 2012?
Make the answer very short. 1.1. What is the difference between the highest and the second highest Balance of Payment (as % of commercial service exports) in Dominica?
Provide a short and direct response. 0.04. What is the difference between the highest and the second highest Balance of Payment (as % of commercial service exports) of Dominican Republic?
Your answer should be compact. 0.26. What is the difference between the highest and the second highest Balance of Payment (as % of commercial service exports) in Ukraine?
Ensure brevity in your answer.  1.52. What is the difference between the highest and the lowest Balance of Payment (as % of commercial service exports) in Dominica?
Your response must be concise. 2.21. What is the difference between the highest and the lowest Balance of Payment (as % of commercial service exports) in Dominican Republic?
Your response must be concise. 3.77. What is the difference between the highest and the lowest Balance of Payment (as % of commercial service exports) in Ukraine?
Keep it short and to the point. 5.81. 